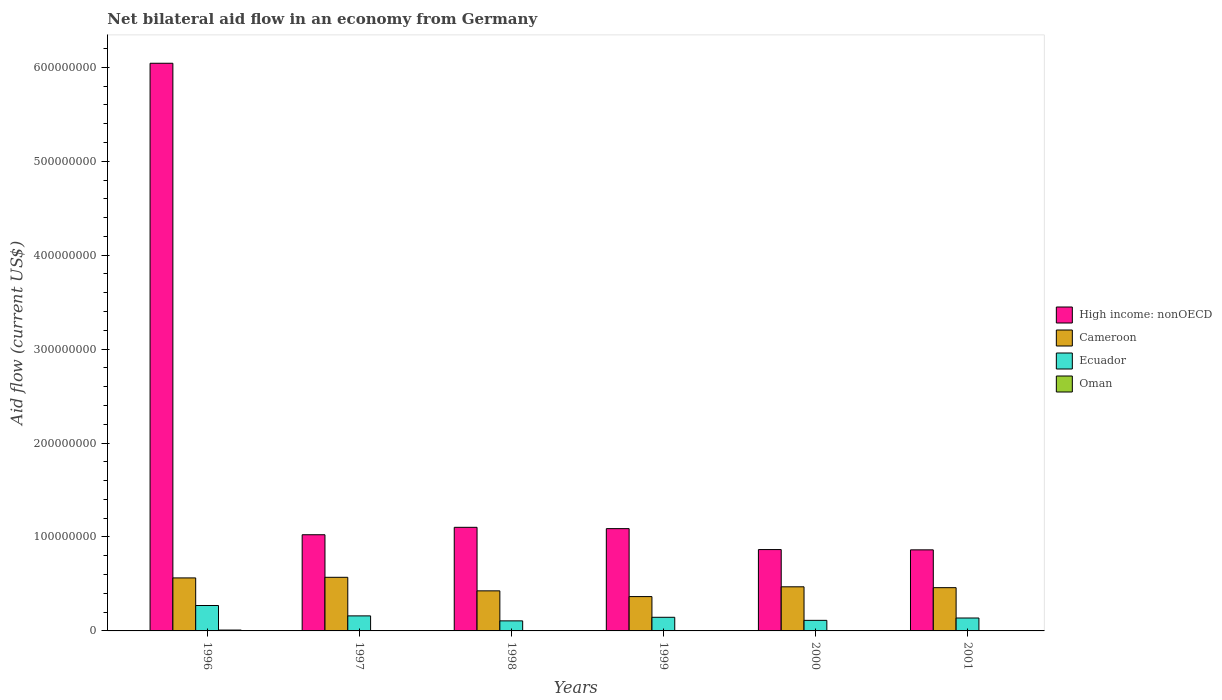How many different coloured bars are there?
Keep it short and to the point. 4. Are the number of bars on each tick of the X-axis equal?
Your response must be concise. Yes. What is the label of the 4th group of bars from the left?
Ensure brevity in your answer.  1999. What is the net bilateral aid flow in High income: nonOECD in 1999?
Give a very brief answer. 1.09e+08. Across all years, what is the maximum net bilateral aid flow in Cameroon?
Offer a very short reply. 5.71e+07. Across all years, what is the minimum net bilateral aid flow in Oman?
Your answer should be compact. 7.00e+04. In which year was the net bilateral aid flow in Oman maximum?
Make the answer very short. 1996. What is the total net bilateral aid flow in Ecuador in the graph?
Your response must be concise. 9.33e+07. What is the difference between the net bilateral aid flow in Cameroon in 1998 and that in 2000?
Your answer should be compact. -4.30e+06. What is the difference between the net bilateral aid flow in High income: nonOECD in 2000 and the net bilateral aid flow in Ecuador in 1999?
Provide a short and direct response. 7.21e+07. What is the average net bilateral aid flow in High income: nonOECD per year?
Keep it short and to the point. 1.83e+08. In the year 1999, what is the difference between the net bilateral aid flow in Ecuador and net bilateral aid flow in High income: nonOECD?
Your answer should be very brief. -9.44e+07. In how many years, is the net bilateral aid flow in High income: nonOECD greater than 360000000 US$?
Give a very brief answer. 1. What is the ratio of the net bilateral aid flow in Cameroon in 1996 to that in 2001?
Your response must be concise. 1.23. Is the net bilateral aid flow in Oman in 1997 less than that in 1999?
Offer a terse response. No. What is the difference between the highest and the second highest net bilateral aid flow in Cameroon?
Provide a succinct answer. 6.50e+05. What is the difference between the highest and the lowest net bilateral aid flow in High income: nonOECD?
Make the answer very short. 5.18e+08. In how many years, is the net bilateral aid flow in High income: nonOECD greater than the average net bilateral aid flow in High income: nonOECD taken over all years?
Keep it short and to the point. 1. Is it the case that in every year, the sum of the net bilateral aid flow in High income: nonOECD and net bilateral aid flow in Ecuador is greater than the sum of net bilateral aid flow in Oman and net bilateral aid flow in Cameroon?
Offer a terse response. No. What does the 4th bar from the left in 2001 represents?
Your answer should be compact. Oman. What does the 1st bar from the right in 1998 represents?
Provide a succinct answer. Oman. Is it the case that in every year, the sum of the net bilateral aid flow in Oman and net bilateral aid flow in High income: nonOECD is greater than the net bilateral aid flow in Ecuador?
Ensure brevity in your answer.  Yes. Does the graph contain any zero values?
Keep it short and to the point. No. Where does the legend appear in the graph?
Keep it short and to the point. Center right. How are the legend labels stacked?
Offer a terse response. Vertical. What is the title of the graph?
Provide a short and direct response. Net bilateral aid flow in an economy from Germany. Does "Dominica" appear as one of the legend labels in the graph?
Provide a succinct answer. No. What is the label or title of the X-axis?
Provide a short and direct response. Years. What is the label or title of the Y-axis?
Ensure brevity in your answer.  Aid flow (current US$). What is the Aid flow (current US$) in High income: nonOECD in 1996?
Your answer should be very brief. 6.04e+08. What is the Aid flow (current US$) in Cameroon in 1996?
Provide a short and direct response. 5.64e+07. What is the Aid flow (current US$) of Ecuador in 1996?
Keep it short and to the point. 2.71e+07. What is the Aid flow (current US$) of Oman in 1996?
Your response must be concise. 9.20e+05. What is the Aid flow (current US$) of High income: nonOECD in 1997?
Provide a succinct answer. 1.02e+08. What is the Aid flow (current US$) of Cameroon in 1997?
Your response must be concise. 5.71e+07. What is the Aid flow (current US$) of Ecuador in 1997?
Make the answer very short. 1.60e+07. What is the Aid flow (current US$) of High income: nonOECD in 1998?
Provide a short and direct response. 1.10e+08. What is the Aid flow (current US$) of Cameroon in 1998?
Your answer should be compact. 4.27e+07. What is the Aid flow (current US$) of Ecuador in 1998?
Keep it short and to the point. 1.07e+07. What is the Aid flow (current US$) in Oman in 1998?
Provide a short and direct response. 4.40e+05. What is the Aid flow (current US$) in High income: nonOECD in 1999?
Keep it short and to the point. 1.09e+08. What is the Aid flow (current US$) in Cameroon in 1999?
Provide a succinct answer. 3.66e+07. What is the Aid flow (current US$) of Ecuador in 1999?
Provide a short and direct response. 1.45e+07. What is the Aid flow (current US$) in Oman in 1999?
Provide a succinct answer. 3.90e+05. What is the Aid flow (current US$) of High income: nonOECD in 2000?
Offer a terse response. 8.66e+07. What is the Aid flow (current US$) of Cameroon in 2000?
Your answer should be compact. 4.70e+07. What is the Aid flow (current US$) in Ecuador in 2000?
Your answer should be compact. 1.12e+07. What is the Aid flow (current US$) of Oman in 2000?
Your answer should be compact. 1.50e+05. What is the Aid flow (current US$) in High income: nonOECD in 2001?
Your response must be concise. 8.63e+07. What is the Aid flow (current US$) in Cameroon in 2001?
Offer a terse response. 4.60e+07. What is the Aid flow (current US$) of Ecuador in 2001?
Provide a succinct answer. 1.37e+07. Across all years, what is the maximum Aid flow (current US$) in High income: nonOECD?
Provide a succinct answer. 6.04e+08. Across all years, what is the maximum Aid flow (current US$) of Cameroon?
Offer a terse response. 5.71e+07. Across all years, what is the maximum Aid flow (current US$) in Ecuador?
Give a very brief answer. 2.71e+07. Across all years, what is the maximum Aid flow (current US$) in Oman?
Your answer should be compact. 9.20e+05. Across all years, what is the minimum Aid flow (current US$) of High income: nonOECD?
Provide a short and direct response. 8.63e+07. Across all years, what is the minimum Aid flow (current US$) of Cameroon?
Offer a terse response. 3.66e+07. Across all years, what is the minimum Aid flow (current US$) of Ecuador?
Offer a very short reply. 1.07e+07. Across all years, what is the minimum Aid flow (current US$) in Oman?
Your answer should be very brief. 7.00e+04. What is the total Aid flow (current US$) of High income: nonOECD in the graph?
Keep it short and to the point. 1.10e+09. What is the total Aid flow (current US$) in Cameroon in the graph?
Offer a terse response. 2.86e+08. What is the total Aid flow (current US$) of Ecuador in the graph?
Offer a terse response. 9.33e+07. What is the total Aid flow (current US$) in Oman in the graph?
Your answer should be compact. 2.39e+06. What is the difference between the Aid flow (current US$) in High income: nonOECD in 1996 and that in 1997?
Your answer should be very brief. 5.02e+08. What is the difference between the Aid flow (current US$) in Cameroon in 1996 and that in 1997?
Provide a short and direct response. -6.50e+05. What is the difference between the Aid flow (current US$) in Ecuador in 1996 and that in 1997?
Make the answer very short. 1.10e+07. What is the difference between the Aid flow (current US$) of Oman in 1996 and that in 1997?
Offer a terse response. 5.00e+05. What is the difference between the Aid flow (current US$) of High income: nonOECD in 1996 and that in 1998?
Your response must be concise. 4.94e+08. What is the difference between the Aid flow (current US$) of Cameroon in 1996 and that in 1998?
Make the answer very short. 1.38e+07. What is the difference between the Aid flow (current US$) in Ecuador in 1996 and that in 1998?
Offer a terse response. 1.64e+07. What is the difference between the Aid flow (current US$) in Oman in 1996 and that in 1998?
Give a very brief answer. 4.80e+05. What is the difference between the Aid flow (current US$) of High income: nonOECD in 1996 and that in 1999?
Ensure brevity in your answer.  4.95e+08. What is the difference between the Aid flow (current US$) in Cameroon in 1996 and that in 1999?
Keep it short and to the point. 1.99e+07. What is the difference between the Aid flow (current US$) in Ecuador in 1996 and that in 1999?
Ensure brevity in your answer.  1.26e+07. What is the difference between the Aid flow (current US$) in Oman in 1996 and that in 1999?
Your response must be concise. 5.30e+05. What is the difference between the Aid flow (current US$) of High income: nonOECD in 1996 and that in 2000?
Provide a short and direct response. 5.18e+08. What is the difference between the Aid flow (current US$) in Cameroon in 1996 and that in 2000?
Your answer should be very brief. 9.47e+06. What is the difference between the Aid flow (current US$) of Ecuador in 1996 and that in 2000?
Give a very brief answer. 1.58e+07. What is the difference between the Aid flow (current US$) of Oman in 1996 and that in 2000?
Ensure brevity in your answer.  7.70e+05. What is the difference between the Aid flow (current US$) in High income: nonOECD in 1996 and that in 2001?
Offer a terse response. 5.18e+08. What is the difference between the Aid flow (current US$) in Cameroon in 1996 and that in 2001?
Provide a short and direct response. 1.04e+07. What is the difference between the Aid flow (current US$) in Ecuador in 1996 and that in 2001?
Your answer should be very brief. 1.33e+07. What is the difference between the Aid flow (current US$) in Oman in 1996 and that in 2001?
Offer a terse response. 8.50e+05. What is the difference between the Aid flow (current US$) in High income: nonOECD in 1997 and that in 1998?
Provide a succinct answer. -7.90e+06. What is the difference between the Aid flow (current US$) in Cameroon in 1997 and that in 1998?
Give a very brief answer. 1.44e+07. What is the difference between the Aid flow (current US$) in Ecuador in 1997 and that in 1998?
Your answer should be compact. 5.31e+06. What is the difference between the Aid flow (current US$) in High income: nonOECD in 1997 and that in 1999?
Offer a very short reply. -6.50e+06. What is the difference between the Aid flow (current US$) of Cameroon in 1997 and that in 1999?
Provide a succinct answer. 2.05e+07. What is the difference between the Aid flow (current US$) in Ecuador in 1997 and that in 1999?
Keep it short and to the point. 1.50e+06. What is the difference between the Aid flow (current US$) in Oman in 1997 and that in 1999?
Your answer should be very brief. 3.00e+04. What is the difference between the Aid flow (current US$) of High income: nonOECD in 1997 and that in 2000?
Provide a succinct answer. 1.58e+07. What is the difference between the Aid flow (current US$) of Cameroon in 1997 and that in 2000?
Your answer should be compact. 1.01e+07. What is the difference between the Aid flow (current US$) in Ecuador in 1997 and that in 2000?
Keep it short and to the point. 4.76e+06. What is the difference between the Aid flow (current US$) of Oman in 1997 and that in 2000?
Keep it short and to the point. 2.70e+05. What is the difference between the Aid flow (current US$) in High income: nonOECD in 1997 and that in 2001?
Your answer should be compact. 1.61e+07. What is the difference between the Aid flow (current US$) of Cameroon in 1997 and that in 2001?
Give a very brief answer. 1.10e+07. What is the difference between the Aid flow (current US$) of Ecuador in 1997 and that in 2001?
Give a very brief answer. 2.27e+06. What is the difference between the Aid flow (current US$) of High income: nonOECD in 1998 and that in 1999?
Give a very brief answer. 1.40e+06. What is the difference between the Aid flow (current US$) of Cameroon in 1998 and that in 1999?
Ensure brevity in your answer.  6.11e+06. What is the difference between the Aid flow (current US$) in Ecuador in 1998 and that in 1999?
Ensure brevity in your answer.  -3.81e+06. What is the difference between the Aid flow (current US$) in High income: nonOECD in 1998 and that in 2000?
Give a very brief answer. 2.37e+07. What is the difference between the Aid flow (current US$) of Cameroon in 1998 and that in 2000?
Offer a very short reply. -4.30e+06. What is the difference between the Aid flow (current US$) of Ecuador in 1998 and that in 2000?
Offer a terse response. -5.50e+05. What is the difference between the Aid flow (current US$) in High income: nonOECD in 1998 and that in 2001?
Offer a very short reply. 2.40e+07. What is the difference between the Aid flow (current US$) in Cameroon in 1998 and that in 2001?
Offer a very short reply. -3.39e+06. What is the difference between the Aid flow (current US$) in Ecuador in 1998 and that in 2001?
Your response must be concise. -3.04e+06. What is the difference between the Aid flow (current US$) of Oman in 1998 and that in 2001?
Keep it short and to the point. 3.70e+05. What is the difference between the Aid flow (current US$) in High income: nonOECD in 1999 and that in 2000?
Keep it short and to the point. 2.23e+07. What is the difference between the Aid flow (current US$) of Cameroon in 1999 and that in 2000?
Keep it short and to the point. -1.04e+07. What is the difference between the Aid flow (current US$) of Ecuador in 1999 and that in 2000?
Offer a very short reply. 3.26e+06. What is the difference between the Aid flow (current US$) of Oman in 1999 and that in 2000?
Make the answer very short. 2.40e+05. What is the difference between the Aid flow (current US$) of High income: nonOECD in 1999 and that in 2001?
Your response must be concise. 2.26e+07. What is the difference between the Aid flow (current US$) in Cameroon in 1999 and that in 2001?
Offer a very short reply. -9.50e+06. What is the difference between the Aid flow (current US$) of Ecuador in 1999 and that in 2001?
Your answer should be compact. 7.70e+05. What is the difference between the Aid flow (current US$) in Oman in 1999 and that in 2001?
Offer a terse response. 3.20e+05. What is the difference between the Aid flow (current US$) in Cameroon in 2000 and that in 2001?
Ensure brevity in your answer.  9.10e+05. What is the difference between the Aid flow (current US$) in Ecuador in 2000 and that in 2001?
Ensure brevity in your answer.  -2.49e+06. What is the difference between the Aid flow (current US$) in Oman in 2000 and that in 2001?
Offer a very short reply. 8.00e+04. What is the difference between the Aid flow (current US$) of High income: nonOECD in 1996 and the Aid flow (current US$) of Cameroon in 1997?
Provide a succinct answer. 5.47e+08. What is the difference between the Aid flow (current US$) of High income: nonOECD in 1996 and the Aid flow (current US$) of Ecuador in 1997?
Provide a succinct answer. 5.88e+08. What is the difference between the Aid flow (current US$) of High income: nonOECD in 1996 and the Aid flow (current US$) of Oman in 1997?
Your answer should be compact. 6.04e+08. What is the difference between the Aid flow (current US$) in Cameroon in 1996 and the Aid flow (current US$) in Ecuador in 1997?
Your answer should be very brief. 4.04e+07. What is the difference between the Aid flow (current US$) of Cameroon in 1996 and the Aid flow (current US$) of Oman in 1997?
Offer a very short reply. 5.60e+07. What is the difference between the Aid flow (current US$) of Ecuador in 1996 and the Aid flow (current US$) of Oman in 1997?
Offer a very short reply. 2.66e+07. What is the difference between the Aid flow (current US$) of High income: nonOECD in 1996 and the Aid flow (current US$) of Cameroon in 1998?
Give a very brief answer. 5.62e+08. What is the difference between the Aid flow (current US$) in High income: nonOECD in 1996 and the Aid flow (current US$) in Ecuador in 1998?
Offer a terse response. 5.94e+08. What is the difference between the Aid flow (current US$) of High income: nonOECD in 1996 and the Aid flow (current US$) of Oman in 1998?
Offer a very short reply. 6.04e+08. What is the difference between the Aid flow (current US$) of Cameroon in 1996 and the Aid flow (current US$) of Ecuador in 1998?
Ensure brevity in your answer.  4.57e+07. What is the difference between the Aid flow (current US$) of Cameroon in 1996 and the Aid flow (current US$) of Oman in 1998?
Provide a succinct answer. 5.60e+07. What is the difference between the Aid flow (current US$) of Ecuador in 1996 and the Aid flow (current US$) of Oman in 1998?
Make the answer very short. 2.66e+07. What is the difference between the Aid flow (current US$) in High income: nonOECD in 1996 and the Aid flow (current US$) in Cameroon in 1999?
Offer a terse response. 5.68e+08. What is the difference between the Aid flow (current US$) of High income: nonOECD in 1996 and the Aid flow (current US$) of Ecuador in 1999?
Your answer should be compact. 5.90e+08. What is the difference between the Aid flow (current US$) in High income: nonOECD in 1996 and the Aid flow (current US$) in Oman in 1999?
Make the answer very short. 6.04e+08. What is the difference between the Aid flow (current US$) in Cameroon in 1996 and the Aid flow (current US$) in Ecuador in 1999?
Provide a succinct answer. 4.19e+07. What is the difference between the Aid flow (current US$) of Cameroon in 1996 and the Aid flow (current US$) of Oman in 1999?
Offer a terse response. 5.60e+07. What is the difference between the Aid flow (current US$) in Ecuador in 1996 and the Aid flow (current US$) in Oman in 1999?
Make the answer very short. 2.67e+07. What is the difference between the Aid flow (current US$) of High income: nonOECD in 1996 and the Aid flow (current US$) of Cameroon in 2000?
Offer a terse response. 5.57e+08. What is the difference between the Aid flow (current US$) of High income: nonOECD in 1996 and the Aid flow (current US$) of Ecuador in 2000?
Give a very brief answer. 5.93e+08. What is the difference between the Aid flow (current US$) in High income: nonOECD in 1996 and the Aid flow (current US$) in Oman in 2000?
Your answer should be very brief. 6.04e+08. What is the difference between the Aid flow (current US$) in Cameroon in 1996 and the Aid flow (current US$) in Ecuador in 2000?
Give a very brief answer. 4.52e+07. What is the difference between the Aid flow (current US$) of Cameroon in 1996 and the Aid flow (current US$) of Oman in 2000?
Give a very brief answer. 5.63e+07. What is the difference between the Aid flow (current US$) in Ecuador in 1996 and the Aid flow (current US$) in Oman in 2000?
Your response must be concise. 2.69e+07. What is the difference between the Aid flow (current US$) of High income: nonOECD in 1996 and the Aid flow (current US$) of Cameroon in 2001?
Give a very brief answer. 5.58e+08. What is the difference between the Aid flow (current US$) of High income: nonOECD in 1996 and the Aid flow (current US$) of Ecuador in 2001?
Provide a succinct answer. 5.91e+08. What is the difference between the Aid flow (current US$) in High income: nonOECD in 1996 and the Aid flow (current US$) in Oman in 2001?
Ensure brevity in your answer.  6.04e+08. What is the difference between the Aid flow (current US$) in Cameroon in 1996 and the Aid flow (current US$) in Ecuador in 2001?
Give a very brief answer. 4.27e+07. What is the difference between the Aid flow (current US$) of Cameroon in 1996 and the Aid flow (current US$) of Oman in 2001?
Provide a succinct answer. 5.64e+07. What is the difference between the Aid flow (current US$) of Ecuador in 1996 and the Aid flow (current US$) of Oman in 2001?
Offer a very short reply. 2.70e+07. What is the difference between the Aid flow (current US$) of High income: nonOECD in 1997 and the Aid flow (current US$) of Cameroon in 1998?
Make the answer very short. 5.97e+07. What is the difference between the Aid flow (current US$) of High income: nonOECD in 1997 and the Aid flow (current US$) of Ecuador in 1998?
Give a very brief answer. 9.17e+07. What is the difference between the Aid flow (current US$) in High income: nonOECD in 1997 and the Aid flow (current US$) in Oman in 1998?
Offer a terse response. 1.02e+08. What is the difference between the Aid flow (current US$) in Cameroon in 1997 and the Aid flow (current US$) in Ecuador in 1998?
Ensure brevity in your answer.  4.64e+07. What is the difference between the Aid flow (current US$) of Cameroon in 1997 and the Aid flow (current US$) of Oman in 1998?
Offer a very short reply. 5.66e+07. What is the difference between the Aid flow (current US$) in Ecuador in 1997 and the Aid flow (current US$) in Oman in 1998?
Give a very brief answer. 1.56e+07. What is the difference between the Aid flow (current US$) in High income: nonOECD in 1997 and the Aid flow (current US$) in Cameroon in 1999?
Your answer should be very brief. 6.58e+07. What is the difference between the Aid flow (current US$) in High income: nonOECD in 1997 and the Aid flow (current US$) in Ecuador in 1999?
Ensure brevity in your answer.  8.79e+07. What is the difference between the Aid flow (current US$) in High income: nonOECD in 1997 and the Aid flow (current US$) in Oman in 1999?
Your answer should be compact. 1.02e+08. What is the difference between the Aid flow (current US$) in Cameroon in 1997 and the Aid flow (current US$) in Ecuador in 1999?
Keep it short and to the point. 4.26e+07. What is the difference between the Aid flow (current US$) of Cameroon in 1997 and the Aid flow (current US$) of Oman in 1999?
Your answer should be very brief. 5.67e+07. What is the difference between the Aid flow (current US$) of Ecuador in 1997 and the Aid flow (current US$) of Oman in 1999?
Your response must be concise. 1.56e+07. What is the difference between the Aid flow (current US$) in High income: nonOECD in 1997 and the Aid flow (current US$) in Cameroon in 2000?
Provide a short and direct response. 5.54e+07. What is the difference between the Aid flow (current US$) of High income: nonOECD in 1997 and the Aid flow (current US$) of Ecuador in 2000?
Your response must be concise. 9.11e+07. What is the difference between the Aid flow (current US$) of High income: nonOECD in 1997 and the Aid flow (current US$) of Oman in 2000?
Your answer should be very brief. 1.02e+08. What is the difference between the Aid flow (current US$) of Cameroon in 1997 and the Aid flow (current US$) of Ecuador in 2000?
Keep it short and to the point. 4.58e+07. What is the difference between the Aid flow (current US$) of Cameroon in 1997 and the Aid flow (current US$) of Oman in 2000?
Provide a short and direct response. 5.69e+07. What is the difference between the Aid flow (current US$) of Ecuador in 1997 and the Aid flow (current US$) of Oman in 2000?
Keep it short and to the point. 1.59e+07. What is the difference between the Aid flow (current US$) of High income: nonOECD in 1997 and the Aid flow (current US$) of Cameroon in 2001?
Make the answer very short. 5.63e+07. What is the difference between the Aid flow (current US$) in High income: nonOECD in 1997 and the Aid flow (current US$) in Ecuador in 2001?
Make the answer very short. 8.86e+07. What is the difference between the Aid flow (current US$) in High income: nonOECD in 1997 and the Aid flow (current US$) in Oman in 2001?
Keep it short and to the point. 1.02e+08. What is the difference between the Aid flow (current US$) in Cameroon in 1997 and the Aid flow (current US$) in Ecuador in 2001?
Provide a succinct answer. 4.33e+07. What is the difference between the Aid flow (current US$) of Cameroon in 1997 and the Aid flow (current US$) of Oman in 2001?
Your answer should be compact. 5.70e+07. What is the difference between the Aid flow (current US$) in Ecuador in 1997 and the Aid flow (current US$) in Oman in 2001?
Offer a terse response. 1.59e+07. What is the difference between the Aid flow (current US$) of High income: nonOECD in 1998 and the Aid flow (current US$) of Cameroon in 1999?
Keep it short and to the point. 7.37e+07. What is the difference between the Aid flow (current US$) of High income: nonOECD in 1998 and the Aid flow (current US$) of Ecuador in 1999?
Provide a short and direct response. 9.58e+07. What is the difference between the Aid flow (current US$) in High income: nonOECD in 1998 and the Aid flow (current US$) in Oman in 1999?
Your answer should be compact. 1.10e+08. What is the difference between the Aid flow (current US$) in Cameroon in 1998 and the Aid flow (current US$) in Ecuador in 1999?
Offer a very short reply. 2.82e+07. What is the difference between the Aid flow (current US$) in Cameroon in 1998 and the Aid flow (current US$) in Oman in 1999?
Your response must be concise. 4.23e+07. What is the difference between the Aid flow (current US$) of Ecuador in 1998 and the Aid flow (current US$) of Oman in 1999?
Keep it short and to the point. 1.03e+07. What is the difference between the Aid flow (current US$) in High income: nonOECD in 1998 and the Aid flow (current US$) in Cameroon in 2000?
Your response must be concise. 6.33e+07. What is the difference between the Aid flow (current US$) of High income: nonOECD in 1998 and the Aid flow (current US$) of Ecuador in 2000?
Keep it short and to the point. 9.90e+07. What is the difference between the Aid flow (current US$) of High income: nonOECD in 1998 and the Aid flow (current US$) of Oman in 2000?
Your response must be concise. 1.10e+08. What is the difference between the Aid flow (current US$) of Cameroon in 1998 and the Aid flow (current US$) of Ecuador in 2000?
Your answer should be compact. 3.14e+07. What is the difference between the Aid flow (current US$) of Cameroon in 1998 and the Aid flow (current US$) of Oman in 2000?
Offer a terse response. 4.25e+07. What is the difference between the Aid flow (current US$) of Ecuador in 1998 and the Aid flow (current US$) of Oman in 2000?
Provide a succinct answer. 1.06e+07. What is the difference between the Aid flow (current US$) in High income: nonOECD in 1998 and the Aid flow (current US$) in Cameroon in 2001?
Your answer should be very brief. 6.42e+07. What is the difference between the Aid flow (current US$) in High income: nonOECD in 1998 and the Aid flow (current US$) in Ecuador in 2001?
Offer a very short reply. 9.66e+07. What is the difference between the Aid flow (current US$) in High income: nonOECD in 1998 and the Aid flow (current US$) in Oman in 2001?
Offer a terse response. 1.10e+08. What is the difference between the Aid flow (current US$) in Cameroon in 1998 and the Aid flow (current US$) in Ecuador in 2001?
Keep it short and to the point. 2.89e+07. What is the difference between the Aid flow (current US$) in Cameroon in 1998 and the Aid flow (current US$) in Oman in 2001?
Provide a succinct answer. 4.26e+07. What is the difference between the Aid flow (current US$) of Ecuador in 1998 and the Aid flow (current US$) of Oman in 2001?
Keep it short and to the point. 1.06e+07. What is the difference between the Aid flow (current US$) of High income: nonOECD in 1999 and the Aid flow (current US$) of Cameroon in 2000?
Offer a terse response. 6.19e+07. What is the difference between the Aid flow (current US$) of High income: nonOECD in 1999 and the Aid flow (current US$) of Ecuador in 2000?
Make the answer very short. 9.76e+07. What is the difference between the Aid flow (current US$) of High income: nonOECD in 1999 and the Aid flow (current US$) of Oman in 2000?
Ensure brevity in your answer.  1.09e+08. What is the difference between the Aid flow (current US$) in Cameroon in 1999 and the Aid flow (current US$) in Ecuador in 2000?
Offer a terse response. 2.53e+07. What is the difference between the Aid flow (current US$) of Cameroon in 1999 and the Aid flow (current US$) of Oman in 2000?
Offer a very short reply. 3.64e+07. What is the difference between the Aid flow (current US$) in Ecuador in 1999 and the Aid flow (current US$) in Oman in 2000?
Your response must be concise. 1.44e+07. What is the difference between the Aid flow (current US$) of High income: nonOECD in 1999 and the Aid flow (current US$) of Cameroon in 2001?
Offer a very short reply. 6.28e+07. What is the difference between the Aid flow (current US$) in High income: nonOECD in 1999 and the Aid flow (current US$) in Ecuador in 2001?
Make the answer very short. 9.52e+07. What is the difference between the Aid flow (current US$) of High income: nonOECD in 1999 and the Aid flow (current US$) of Oman in 2001?
Your answer should be very brief. 1.09e+08. What is the difference between the Aid flow (current US$) of Cameroon in 1999 and the Aid flow (current US$) of Ecuador in 2001?
Your answer should be compact. 2.28e+07. What is the difference between the Aid flow (current US$) of Cameroon in 1999 and the Aid flow (current US$) of Oman in 2001?
Ensure brevity in your answer.  3.65e+07. What is the difference between the Aid flow (current US$) in Ecuador in 1999 and the Aid flow (current US$) in Oman in 2001?
Keep it short and to the point. 1.44e+07. What is the difference between the Aid flow (current US$) of High income: nonOECD in 2000 and the Aid flow (current US$) of Cameroon in 2001?
Keep it short and to the point. 4.06e+07. What is the difference between the Aid flow (current US$) of High income: nonOECD in 2000 and the Aid flow (current US$) of Ecuador in 2001?
Make the answer very short. 7.29e+07. What is the difference between the Aid flow (current US$) in High income: nonOECD in 2000 and the Aid flow (current US$) in Oman in 2001?
Ensure brevity in your answer.  8.65e+07. What is the difference between the Aid flow (current US$) in Cameroon in 2000 and the Aid flow (current US$) in Ecuador in 2001?
Your response must be concise. 3.32e+07. What is the difference between the Aid flow (current US$) of Cameroon in 2000 and the Aid flow (current US$) of Oman in 2001?
Ensure brevity in your answer.  4.69e+07. What is the difference between the Aid flow (current US$) of Ecuador in 2000 and the Aid flow (current US$) of Oman in 2001?
Offer a very short reply. 1.12e+07. What is the average Aid flow (current US$) of High income: nonOECD per year?
Provide a succinct answer. 1.83e+08. What is the average Aid flow (current US$) in Cameroon per year?
Provide a succinct answer. 4.76e+07. What is the average Aid flow (current US$) in Ecuador per year?
Your response must be concise. 1.55e+07. What is the average Aid flow (current US$) in Oman per year?
Offer a terse response. 3.98e+05. In the year 1996, what is the difference between the Aid flow (current US$) in High income: nonOECD and Aid flow (current US$) in Cameroon?
Make the answer very short. 5.48e+08. In the year 1996, what is the difference between the Aid flow (current US$) in High income: nonOECD and Aid flow (current US$) in Ecuador?
Your response must be concise. 5.77e+08. In the year 1996, what is the difference between the Aid flow (current US$) in High income: nonOECD and Aid flow (current US$) in Oman?
Provide a short and direct response. 6.03e+08. In the year 1996, what is the difference between the Aid flow (current US$) of Cameroon and Aid flow (current US$) of Ecuador?
Your answer should be compact. 2.94e+07. In the year 1996, what is the difference between the Aid flow (current US$) of Cameroon and Aid flow (current US$) of Oman?
Make the answer very short. 5.55e+07. In the year 1996, what is the difference between the Aid flow (current US$) in Ecuador and Aid flow (current US$) in Oman?
Offer a very short reply. 2.61e+07. In the year 1997, what is the difference between the Aid flow (current US$) of High income: nonOECD and Aid flow (current US$) of Cameroon?
Offer a terse response. 4.53e+07. In the year 1997, what is the difference between the Aid flow (current US$) in High income: nonOECD and Aid flow (current US$) in Ecuador?
Your answer should be very brief. 8.64e+07. In the year 1997, what is the difference between the Aid flow (current US$) of High income: nonOECD and Aid flow (current US$) of Oman?
Provide a succinct answer. 1.02e+08. In the year 1997, what is the difference between the Aid flow (current US$) of Cameroon and Aid flow (current US$) of Ecuador?
Your answer should be compact. 4.11e+07. In the year 1997, what is the difference between the Aid flow (current US$) in Cameroon and Aid flow (current US$) in Oman?
Make the answer very short. 5.67e+07. In the year 1997, what is the difference between the Aid flow (current US$) of Ecuador and Aid flow (current US$) of Oman?
Provide a succinct answer. 1.56e+07. In the year 1998, what is the difference between the Aid flow (current US$) of High income: nonOECD and Aid flow (current US$) of Cameroon?
Provide a short and direct response. 6.76e+07. In the year 1998, what is the difference between the Aid flow (current US$) of High income: nonOECD and Aid flow (current US$) of Ecuador?
Make the answer very short. 9.96e+07. In the year 1998, what is the difference between the Aid flow (current US$) of High income: nonOECD and Aid flow (current US$) of Oman?
Keep it short and to the point. 1.10e+08. In the year 1998, what is the difference between the Aid flow (current US$) in Cameroon and Aid flow (current US$) in Ecuador?
Give a very brief answer. 3.20e+07. In the year 1998, what is the difference between the Aid flow (current US$) of Cameroon and Aid flow (current US$) of Oman?
Offer a terse response. 4.22e+07. In the year 1998, what is the difference between the Aid flow (current US$) in Ecuador and Aid flow (current US$) in Oman?
Give a very brief answer. 1.03e+07. In the year 1999, what is the difference between the Aid flow (current US$) of High income: nonOECD and Aid flow (current US$) of Cameroon?
Offer a terse response. 7.23e+07. In the year 1999, what is the difference between the Aid flow (current US$) of High income: nonOECD and Aid flow (current US$) of Ecuador?
Provide a succinct answer. 9.44e+07. In the year 1999, what is the difference between the Aid flow (current US$) of High income: nonOECD and Aid flow (current US$) of Oman?
Keep it short and to the point. 1.08e+08. In the year 1999, what is the difference between the Aid flow (current US$) of Cameroon and Aid flow (current US$) of Ecuador?
Your answer should be very brief. 2.20e+07. In the year 1999, what is the difference between the Aid flow (current US$) in Cameroon and Aid flow (current US$) in Oman?
Provide a short and direct response. 3.62e+07. In the year 1999, what is the difference between the Aid flow (current US$) of Ecuador and Aid flow (current US$) of Oman?
Make the answer very short. 1.41e+07. In the year 2000, what is the difference between the Aid flow (current US$) of High income: nonOECD and Aid flow (current US$) of Cameroon?
Ensure brevity in your answer.  3.96e+07. In the year 2000, what is the difference between the Aid flow (current US$) in High income: nonOECD and Aid flow (current US$) in Ecuador?
Keep it short and to the point. 7.54e+07. In the year 2000, what is the difference between the Aid flow (current US$) in High income: nonOECD and Aid flow (current US$) in Oman?
Your response must be concise. 8.65e+07. In the year 2000, what is the difference between the Aid flow (current US$) of Cameroon and Aid flow (current US$) of Ecuador?
Make the answer very short. 3.57e+07. In the year 2000, what is the difference between the Aid flow (current US$) of Cameroon and Aid flow (current US$) of Oman?
Offer a very short reply. 4.68e+07. In the year 2000, what is the difference between the Aid flow (current US$) in Ecuador and Aid flow (current US$) in Oman?
Your answer should be very brief. 1.11e+07. In the year 2001, what is the difference between the Aid flow (current US$) in High income: nonOECD and Aid flow (current US$) in Cameroon?
Provide a short and direct response. 4.03e+07. In the year 2001, what is the difference between the Aid flow (current US$) in High income: nonOECD and Aid flow (current US$) in Ecuador?
Your answer should be compact. 7.26e+07. In the year 2001, what is the difference between the Aid flow (current US$) in High income: nonOECD and Aid flow (current US$) in Oman?
Keep it short and to the point. 8.62e+07. In the year 2001, what is the difference between the Aid flow (current US$) in Cameroon and Aid flow (current US$) in Ecuador?
Your answer should be very brief. 3.23e+07. In the year 2001, what is the difference between the Aid flow (current US$) of Cameroon and Aid flow (current US$) of Oman?
Your answer should be very brief. 4.60e+07. In the year 2001, what is the difference between the Aid flow (current US$) of Ecuador and Aid flow (current US$) of Oman?
Your answer should be compact. 1.37e+07. What is the ratio of the Aid flow (current US$) of High income: nonOECD in 1996 to that in 1997?
Offer a very short reply. 5.9. What is the ratio of the Aid flow (current US$) in Cameroon in 1996 to that in 1997?
Your response must be concise. 0.99. What is the ratio of the Aid flow (current US$) of Ecuador in 1996 to that in 1997?
Your answer should be very brief. 1.69. What is the ratio of the Aid flow (current US$) of Oman in 1996 to that in 1997?
Provide a succinct answer. 2.19. What is the ratio of the Aid flow (current US$) in High income: nonOECD in 1996 to that in 1998?
Keep it short and to the point. 5.48. What is the ratio of the Aid flow (current US$) in Cameroon in 1996 to that in 1998?
Your response must be concise. 1.32. What is the ratio of the Aid flow (current US$) of Ecuador in 1996 to that in 1998?
Offer a terse response. 2.53. What is the ratio of the Aid flow (current US$) of Oman in 1996 to that in 1998?
Your answer should be compact. 2.09. What is the ratio of the Aid flow (current US$) in High income: nonOECD in 1996 to that in 1999?
Your response must be concise. 5.55. What is the ratio of the Aid flow (current US$) in Cameroon in 1996 to that in 1999?
Keep it short and to the point. 1.54. What is the ratio of the Aid flow (current US$) in Ecuador in 1996 to that in 1999?
Provide a succinct answer. 1.86. What is the ratio of the Aid flow (current US$) of Oman in 1996 to that in 1999?
Provide a succinct answer. 2.36. What is the ratio of the Aid flow (current US$) in High income: nonOECD in 1996 to that in 2000?
Offer a terse response. 6.98. What is the ratio of the Aid flow (current US$) in Cameroon in 1996 to that in 2000?
Give a very brief answer. 1.2. What is the ratio of the Aid flow (current US$) in Ecuador in 1996 to that in 2000?
Give a very brief answer. 2.41. What is the ratio of the Aid flow (current US$) in Oman in 1996 to that in 2000?
Offer a very short reply. 6.13. What is the ratio of the Aid flow (current US$) of High income: nonOECD in 1996 to that in 2001?
Your answer should be compact. 7. What is the ratio of the Aid flow (current US$) in Cameroon in 1996 to that in 2001?
Ensure brevity in your answer.  1.23. What is the ratio of the Aid flow (current US$) in Ecuador in 1996 to that in 2001?
Provide a succinct answer. 1.97. What is the ratio of the Aid flow (current US$) of Oman in 1996 to that in 2001?
Provide a short and direct response. 13.14. What is the ratio of the Aid flow (current US$) in High income: nonOECD in 1997 to that in 1998?
Your answer should be compact. 0.93. What is the ratio of the Aid flow (current US$) of Cameroon in 1997 to that in 1998?
Your answer should be very brief. 1.34. What is the ratio of the Aid flow (current US$) in Ecuador in 1997 to that in 1998?
Offer a very short reply. 1.5. What is the ratio of the Aid flow (current US$) in Oman in 1997 to that in 1998?
Offer a very short reply. 0.95. What is the ratio of the Aid flow (current US$) of High income: nonOECD in 1997 to that in 1999?
Your answer should be very brief. 0.94. What is the ratio of the Aid flow (current US$) in Cameroon in 1997 to that in 1999?
Give a very brief answer. 1.56. What is the ratio of the Aid flow (current US$) in Ecuador in 1997 to that in 1999?
Offer a terse response. 1.1. What is the ratio of the Aid flow (current US$) in Oman in 1997 to that in 1999?
Give a very brief answer. 1.08. What is the ratio of the Aid flow (current US$) of High income: nonOECD in 1997 to that in 2000?
Offer a very short reply. 1.18. What is the ratio of the Aid flow (current US$) in Cameroon in 1997 to that in 2000?
Keep it short and to the point. 1.22. What is the ratio of the Aid flow (current US$) in Ecuador in 1997 to that in 2000?
Give a very brief answer. 1.42. What is the ratio of the Aid flow (current US$) in High income: nonOECD in 1997 to that in 2001?
Offer a terse response. 1.19. What is the ratio of the Aid flow (current US$) in Cameroon in 1997 to that in 2001?
Provide a succinct answer. 1.24. What is the ratio of the Aid flow (current US$) in Ecuador in 1997 to that in 2001?
Offer a terse response. 1.17. What is the ratio of the Aid flow (current US$) of Oman in 1997 to that in 2001?
Your answer should be very brief. 6. What is the ratio of the Aid flow (current US$) of High income: nonOECD in 1998 to that in 1999?
Make the answer very short. 1.01. What is the ratio of the Aid flow (current US$) of Cameroon in 1998 to that in 1999?
Give a very brief answer. 1.17. What is the ratio of the Aid flow (current US$) of Ecuador in 1998 to that in 1999?
Your answer should be very brief. 0.74. What is the ratio of the Aid flow (current US$) of Oman in 1998 to that in 1999?
Your answer should be very brief. 1.13. What is the ratio of the Aid flow (current US$) of High income: nonOECD in 1998 to that in 2000?
Your answer should be compact. 1.27. What is the ratio of the Aid flow (current US$) of Cameroon in 1998 to that in 2000?
Your answer should be compact. 0.91. What is the ratio of the Aid flow (current US$) in Ecuador in 1998 to that in 2000?
Ensure brevity in your answer.  0.95. What is the ratio of the Aid flow (current US$) of Oman in 1998 to that in 2000?
Keep it short and to the point. 2.93. What is the ratio of the Aid flow (current US$) of High income: nonOECD in 1998 to that in 2001?
Your answer should be compact. 1.28. What is the ratio of the Aid flow (current US$) of Cameroon in 1998 to that in 2001?
Your answer should be very brief. 0.93. What is the ratio of the Aid flow (current US$) of Ecuador in 1998 to that in 2001?
Your answer should be compact. 0.78. What is the ratio of the Aid flow (current US$) of Oman in 1998 to that in 2001?
Give a very brief answer. 6.29. What is the ratio of the Aid flow (current US$) in High income: nonOECD in 1999 to that in 2000?
Keep it short and to the point. 1.26. What is the ratio of the Aid flow (current US$) in Cameroon in 1999 to that in 2000?
Keep it short and to the point. 0.78. What is the ratio of the Aid flow (current US$) in Ecuador in 1999 to that in 2000?
Provide a short and direct response. 1.29. What is the ratio of the Aid flow (current US$) of Oman in 1999 to that in 2000?
Provide a short and direct response. 2.6. What is the ratio of the Aid flow (current US$) in High income: nonOECD in 1999 to that in 2001?
Your answer should be very brief. 1.26. What is the ratio of the Aid flow (current US$) in Cameroon in 1999 to that in 2001?
Give a very brief answer. 0.79. What is the ratio of the Aid flow (current US$) of Ecuador in 1999 to that in 2001?
Keep it short and to the point. 1.06. What is the ratio of the Aid flow (current US$) of Oman in 1999 to that in 2001?
Keep it short and to the point. 5.57. What is the ratio of the Aid flow (current US$) in Cameroon in 2000 to that in 2001?
Offer a very short reply. 1.02. What is the ratio of the Aid flow (current US$) of Ecuador in 2000 to that in 2001?
Provide a short and direct response. 0.82. What is the ratio of the Aid flow (current US$) in Oman in 2000 to that in 2001?
Keep it short and to the point. 2.14. What is the difference between the highest and the second highest Aid flow (current US$) in High income: nonOECD?
Your response must be concise. 4.94e+08. What is the difference between the highest and the second highest Aid flow (current US$) in Cameroon?
Make the answer very short. 6.50e+05. What is the difference between the highest and the second highest Aid flow (current US$) of Ecuador?
Provide a short and direct response. 1.10e+07. What is the difference between the highest and the lowest Aid flow (current US$) of High income: nonOECD?
Give a very brief answer. 5.18e+08. What is the difference between the highest and the lowest Aid flow (current US$) in Cameroon?
Give a very brief answer. 2.05e+07. What is the difference between the highest and the lowest Aid flow (current US$) of Ecuador?
Offer a terse response. 1.64e+07. What is the difference between the highest and the lowest Aid flow (current US$) in Oman?
Your answer should be very brief. 8.50e+05. 